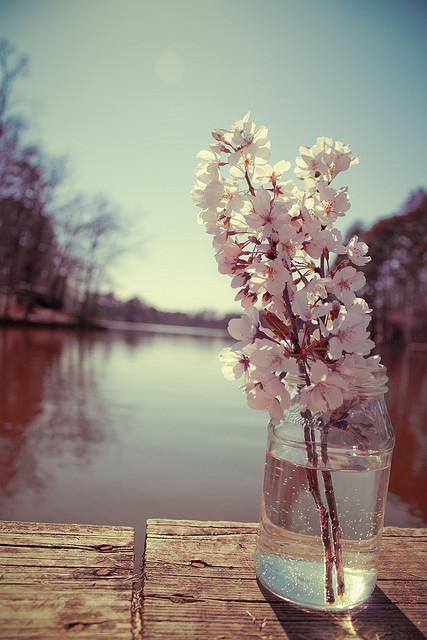What is the flower in?
Write a very short answer. Jar. Is the seedling a hybrid?
Write a very short answer. No. What kind of plant is this?
Keep it brief. Flower. What color is the flower?
Short answer required. Pink. Is this beer in a wine glass?
Be succinct. No. Does someone have a green thumb?
Quick response, please. Yes. Are there real flowers in this picture?
Short answer required. Yes. What are the flowers made from?
Give a very brief answer. Petals. How many leafs does this flower have?
Keep it brief. 0. 